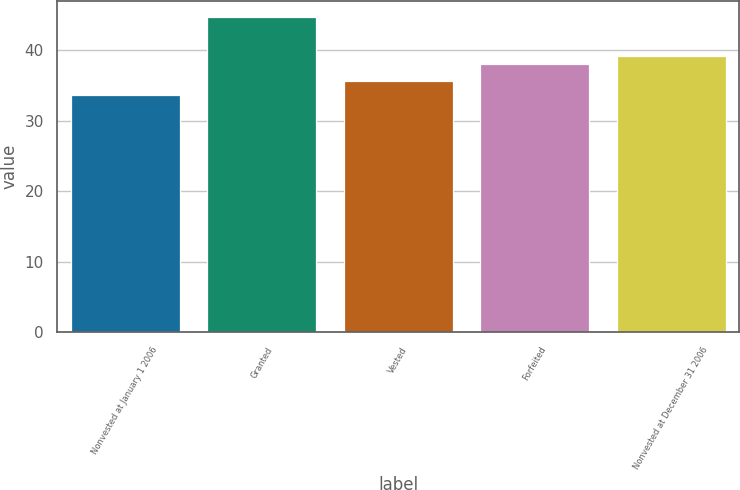<chart> <loc_0><loc_0><loc_500><loc_500><bar_chart><fcel>Nonvested at January 1 2006<fcel>Granted<fcel>Vested<fcel>Forfeited<fcel>Nonvested at December 31 2006<nl><fcel>33.6<fcel>44.76<fcel>35.65<fcel>38.01<fcel>39.13<nl></chart> 